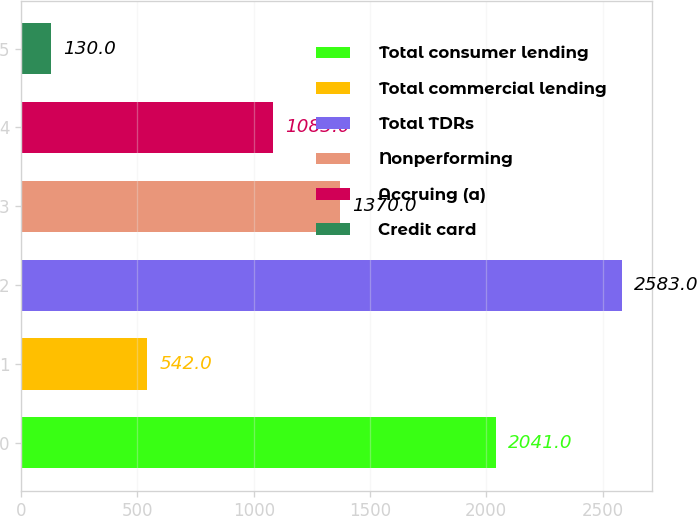Convert chart. <chart><loc_0><loc_0><loc_500><loc_500><bar_chart><fcel>Total consumer lending<fcel>Total commercial lending<fcel>Total TDRs<fcel>Nonperforming<fcel>Accruing (a)<fcel>Credit card<nl><fcel>2041<fcel>542<fcel>2583<fcel>1370<fcel>1083<fcel>130<nl></chart> 